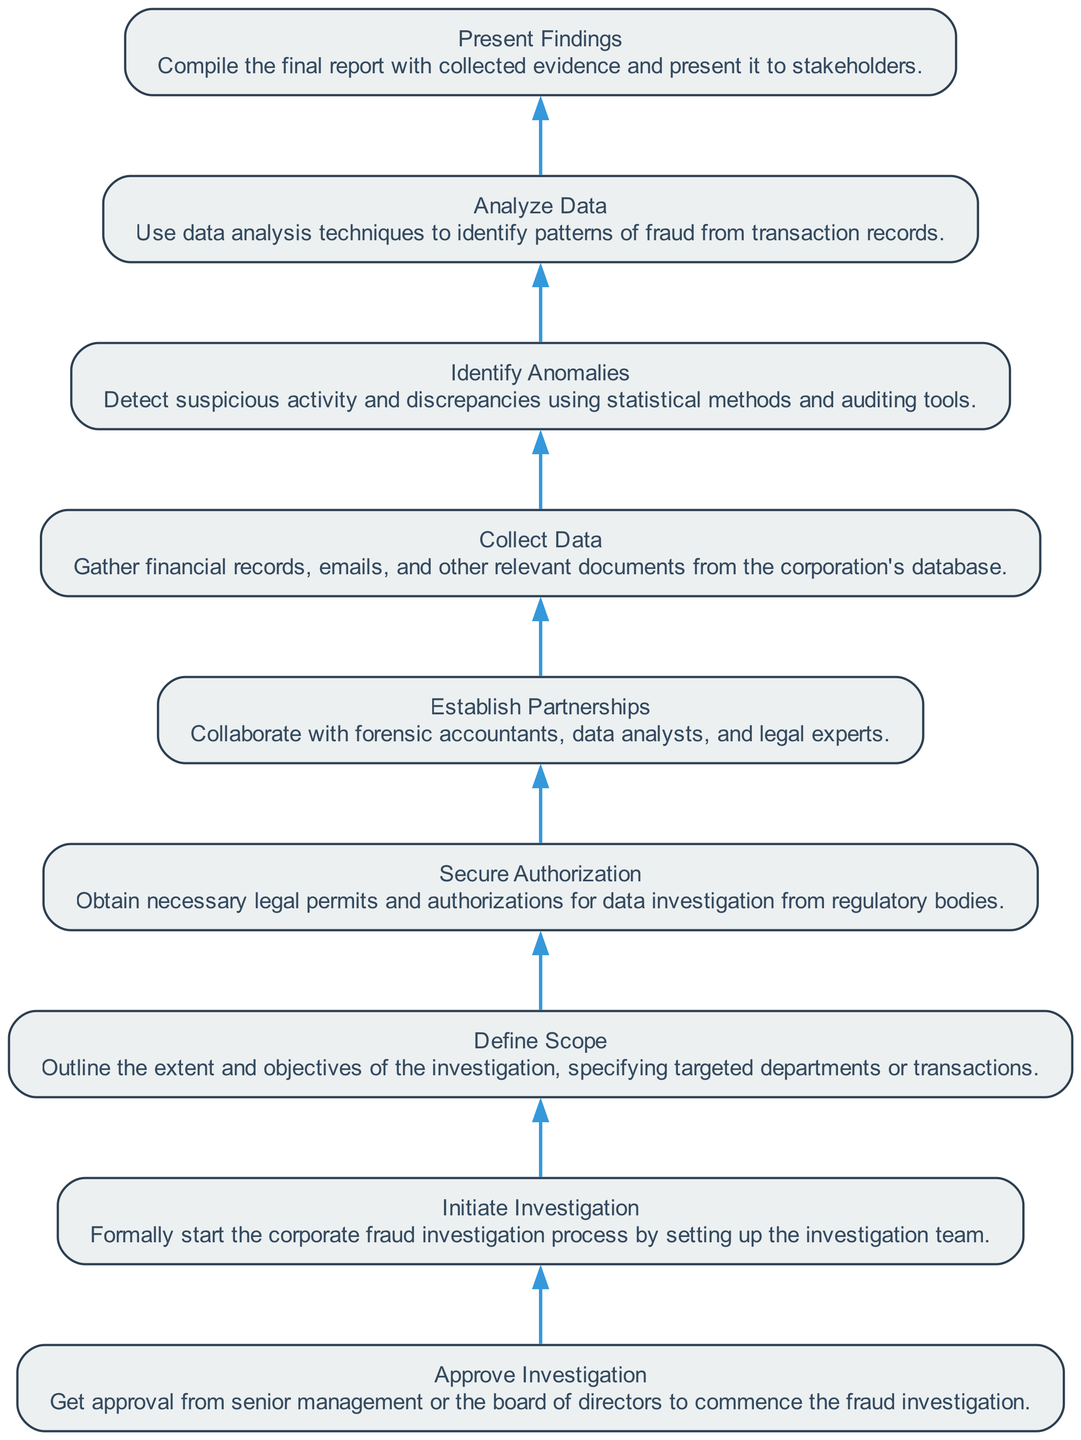What is the final step in the investigation process? The final step, as indicated at the top of the flowchart, is "Present Findings," which entails compiling the final report and presenting it to stakeholders.
Answer: Present Findings How many nodes are in this flowchart? The flowchart comprises a total of eight nodes, representing the different steps in the investigation process.
Answer: Eight Which step comes immediately before "Analyze Data"? The node "Identify Anomalies" directly leads into "Analyze Data," making it the step that immediately precedes it.
Answer: Identify Anomalies What is the relationship between "Secure Authorization" and "Collect Data"? "Secure Authorization" is a prerequisite for "Collect Data," indicating that you must obtain legal permits before gathering relevant documents.
Answer: Secure Authorization → Collect Data Which step has no dependencies? The step "Approve Investigation" has no predecessors listed, meaning it can be initiated without any prior steps from the flowchart.
Answer: Approve Investigation What are the objectives defined in the "Define Scope" step? The "Define Scope" step focuses on outlining the extent and objectives of the investigation, including targeted departments or transactions, making it strategic to the entire process.
Answer: Outline the extent and objectives Which node indicates collaboration with external experts? "Establish Partnerships" highlights the importance of collaborating with forensic accountants, data analysts, and legal experts, indicating a mutual effort in the investigation.
Answer: Establish Partnerships What must be obtained before starting the investigation? Prior to initiating the investigation process, the necessary approval is required from senior management or the board of directors, as indicated in the flowchart.
Answer: Approval 